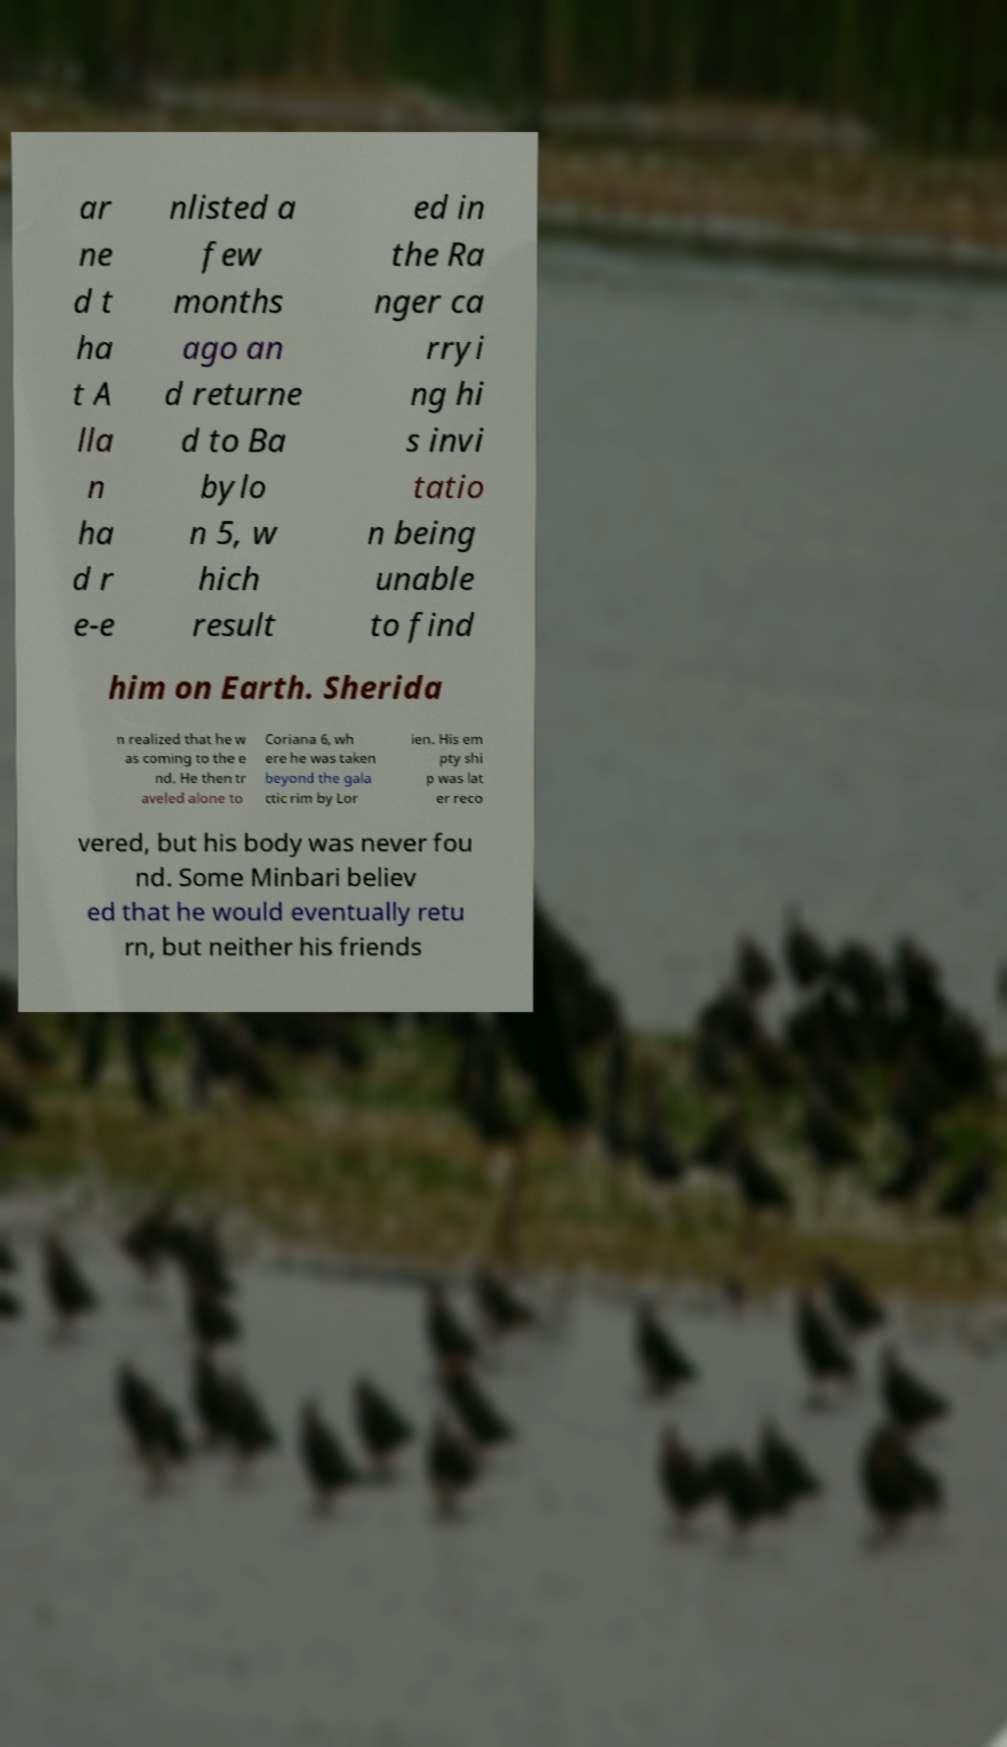For documentation purposes, I need the text within this image transcribed. Could you provide that? ar ne d t ha t A lla n ha d r e-e nlisted a few months ago an d returne d to Ba bylo n 5, w hich result ed in the Ra nger ca rryi ng hi s invi tatio n being unable to find him on Earth. Sherida n realized that he w as coming to the e nd. He then tr aveled alone to Coriana 6, wh ere he was taken beyond the gala ctic rim by Lor ien. His em pty shi p was lat er reco vered, but his body was never fou nd. Some Minbari believ ed that he would eventually retu rn, but neither his friends 